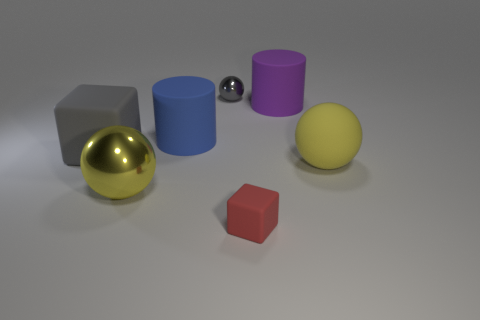What is the shape of the yellow thing on the right side of the big purple thing to the right of the red thing?
Make the answer very short. Sphere. What number of other things are there of the same color as the big rubber sphere?
Provide a short and direct response. 1. Are the block on the right side of the gray matte block and the big yellow sphere on the right side of the tiny gray sphere made of the same material?
Make the answer very short. Yes. How big is the yellow sphere that is in front of the matte sphere?
Give a very brief answer. Large. What is the material of the other yellow thing that is the same shape as the yellow rubber thing?
Provide a short and direct response. Metal. Is there anything else that has the same size as the gray sphere?
Offer a very short reply. Yes. There is a small object that is behind the red thing; what is its shape?
Your answer should be very brief. Sphere. What number of large gray objects have the same shape as the red thing?
Your response must be concise. 1. Are there the same number of big matte cubes behind the tiny gray shiny ball and big cylinders on the right side of the blue rubber object?
Your response must be concise. No. Are there any small gray things that have the same material as the big block?
Your answer should be compact. No. 